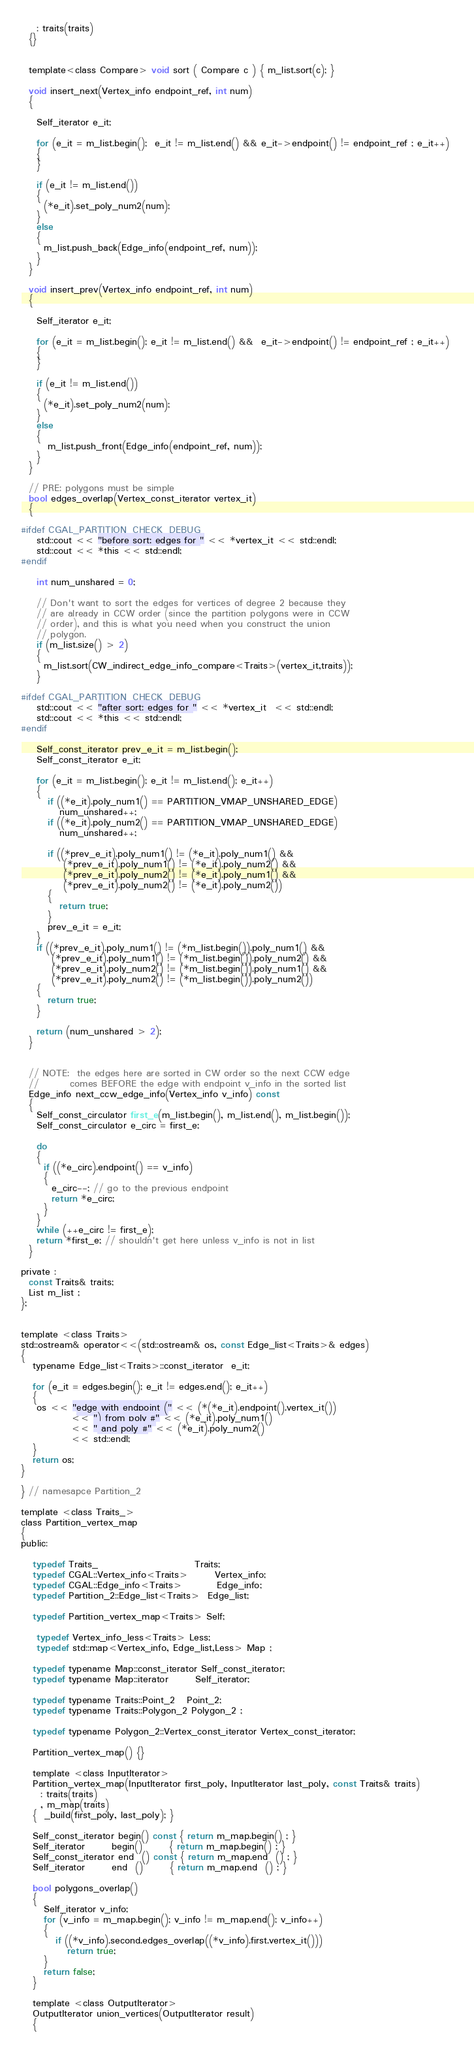<code> <loc_0><loc_0><loc_500><loc_500><_C_>    : traits(traits)
  {}
  
  
  template<class Compare> void sort ( Compare c ) { m_list.sort(c); }

  void insert_next(Vertex_info endpoint_ref, int num)
  {

    Self_iterator e_it;

    for (e_it = m_list.begin();  e_it != m_list.end() && e_it->endpoint() != endpoint_ref ; e_it++) 
    {
    }

    if (e_it != m_list.end())
    {
      (*e_it).set_poly_num2(num);
    }
    else
    {
      m_list.push_back(Edge_info(endpoint_ref, num));
    }
  }

  void insert_prev(Vertex_info endpoint_ref, int num)
  {

    Self_iterator e_it;

    for (e_it = m_list.begin(); e_it != m_list.end() &&  e_it->endpoint() != endpoint_ref ; e_it++) 
    {
    }

    if (e_it != m_list.end())
    {
      (*e_it).set_poly_num2(num);
    }
    else
    {
       m_list.push_front(Edge_info(endpoint_ref, num));
    }
  }

  // PRE: polygons must be simple
  bool edges_overlap(Vertex_const_iterator vertex_it) 
  {

#ifdef CGAL_PARTITION_CHECK_DEBUG
    std::cout << "before sort: edges for " << *vertex_it << std::endl;
    std::cout << *this << std::endl;
#endif

    int num_unshared = 0;

    // Don't want to sort the edges for vertices of degree 2 because they
    // are already in CCW order (since the partition polygons were in CCW
    // order), and this is what you need when you construct the union 
    // polygon.
    if (m_list.size() > 2)
    {
      m_list.sort(CW_indirect_edge_info_compare<Traits>(vertex_it,traits));
    }

#ifdef CGAL_PARTITION_CHECK_DEBUG
    std::cout << "after sort: edges for " << *vertex_it  << std::endl;
    std::cout << *this << std::endl;
#endif

    Self_const_iterator prev_e_it = m_list.begin();
    Self_const_iterator e_it;

    for (e_it = m_list.begin(); e_it != m_list.end(); e_it++)
    {
       if ((*e_it).poly_num1() == PARTITION_VMAP_UNSHARED_EDGE) 
          num_unshared++;
       if ((*e_it).poly_num2() == PARTITION_VMAP_UNSHARED_EDGE) 
          num_unshared++;

       if ((*prev_e_it).poly_num1() != (*e_it).poly_num1() &&
           (*prev_e_it).poly_num1() != (*e_it).poly_num2() &&
           (*prev_e_it).poly_num2() != (*e_it).poly_num1() &&
           (*prev_e_it).poly_num2() != (*e_it).poly_num2())
       {
          return true;
       }
       prev_e_it = e_it;
    }
    if ((*prev_e_it).poly_num1() != (*m_list.begin()).poly_num1() &&
        (*prev_e_it).poly_num1() != (*m_list.begin()).poly_num2() &&
        (*prev_e_it).poly_num2() != (*m_list.begin()).poly_num1() &&
        (*prev_e_it).poly_num2() != (*m_list.begin()).poly_num2())
    {
       return true;
    }

    return (num_unshared > 2);
  }


  // NOTE:  the edges here are sorted in CW order so the next CCW edge
  //        comes BEFORE the edge with endpoint v_info in the sorted list
  Edge_info next_ccw_edge_info(Vertex_info v_info) const
  {
    Self_const_circulator first_e(m_list.begin(), m_list.end(), m_list.begin());
    Self_const_circulator e_circ = first_e;

    do
    {
      if ((*e_circ).endpoint() == v_info)
      {
        e_circ--; // go to the previous endpoint 
        return *e_circ;
      }
    }
    while (++e_circ != first_e);
    return *first_e; // shouldn't get here unless v_info is not in list
  }

private :
  const Traits& traits;
  List m_list ;
};


template <class Traits>
std::ostream& operator<<(std::ostream& os, const Edge_list<Traits>& edges) 
{
   typename Edge_list<Traits>::const_iterator  e_it;

   for (e_it = edges.begin(); e_it != edges.end(); e_it++)
   {
    os << "edge with endpoint (" << (*(*e_it).endpoint().vertex_it())
             << ") from poly #" << (*e_it).poly_num1() 
             << " and poly #" << (*e_it).poly_num2() 
             << std::endl;
   }
   return os;
}

} // namesapce Partition_2

template <class Traits_>
class Partition_vertex_map  
{
public:

   typedef Traits_                         Traits;
   typedef CGAL::Vertex_info<Traits>       Vertex_info;
   typedef CGAL::Edge_info<Traits>         Edge_info;
   typedef Partition_2::Edge_list<Traits>  Edge_list;  

   typedef Partition_vertex_map<Traits> Self;

    typedef Vertex_info_less<Traits> Less;
    typedef std::map<Vertex_info, Edge_list,Less> Map ;

   typedef typename Map::const_iterator Self_const_iterator;
   typedef typename Map::iterator       Self_iterator;

   typedef typename Traits::Point_2   Point_2;
   typedef typename Traits::Polygon_2 Polygon_2 ;

   typedef typename Polygon_2::Vertex_const_iterator Vertex_const_iterator;

   Partition_vertex_map() {}

   template <class InputIterator>
   Partition_vertex_map(InputIterator first_poly, InputIterator last_poly, const Traits& traits)
     : traits(traits)
     , m_map(traits)
   {  _build(first_poly, last_poly); }
  
   Self_const_iterator begin() const { return m_map.begin() ; }
   Self_iterator       begin()       { return m_map.begin() ; }
   Self_const_iterator end  () const { return m_map.end  () ; }
   Self_iterator       end  ()       { return m_map.end  () ; }

   bool polygons_overlap()
   {
      Self_iterator v_info;
      for (v_info = m_map.begin(); v_info != m_map.end(); v_info++)
      {
         if ((*v_info).second.edges_overlap((*v_info).first.vertex_it())) 
            return true;
      }
      return false;
   }

   template <class OutputIterator>
   OutputIterator union_vertices(OutputIterator result)
   {</code> 